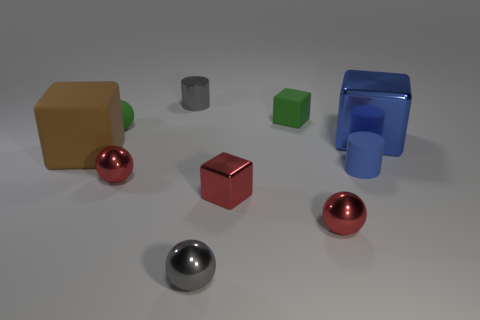There is a blue thing that is the same material as the large brown thing; what size is it?
Make the answer very short. Small. Is there anything else of the same color as the big shiny block?
Your answer should be very brief. Yes. The cylinder to the left of the green rubber cube is what color?
Provide a succinct answer. Gray. Are there any big brown matte cubes that are behind the sphere that is behind the large cube that is on the right side of the small red shiny cube?
Keep it short and to the point. No. Are there more big shiny objects that are on the left side of the tiny green ball than objects?
Give a very brief answer. No. There is a blue thing that is on the right side of the tiny blue cylinder; does it have the same shape as the large brown thing?
Keep it short and to the point. Yes. What number of things are either tiny red cylinders or tiny metallic cubes in front of the brown thing?
Offer a very short reply. 1. There is a rubber thing that is both in front of the blue metallic thing and left of the tiny metallic cube; what is its size?
Offer a very short reply. Large. Is the number of small red shiny things on the left side of the brown matte thing greater than the number of matte things that are to the left of the gray shiny ball?
Give a very brief answer. No. Do the large rubber object and the big object that is on the right side of the large brown object have the same shape?
Offer a very short reply. Yes. 